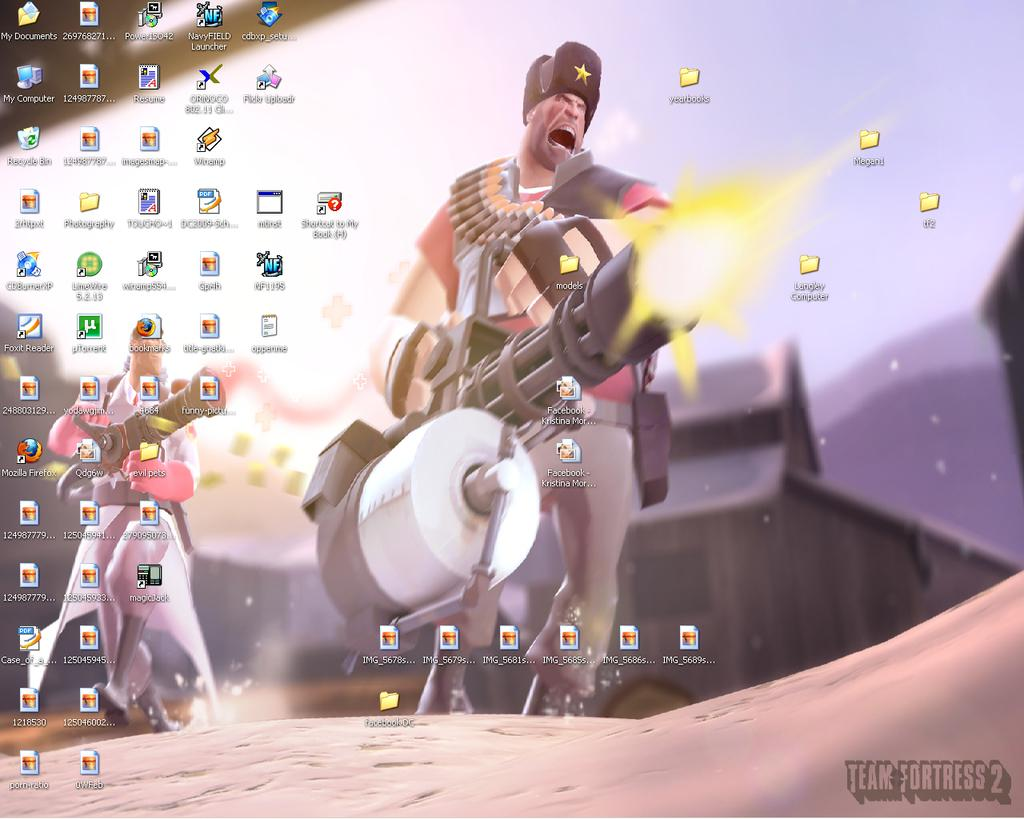What type of characters can be seen in the image? There are animated characters in the image. What else can be seen in the image besides the animated characters? There are other things visible in the image, such as icons. Can you describe the icons in the image? Yes, there are icons in the image. Is there any text or logo visible on the image? Yes, there is a watermark on the image. What type of wax can be seen melting in the image? There is no wax present in the image. How does the drawer open in the image? There is no drawer present in the image. 